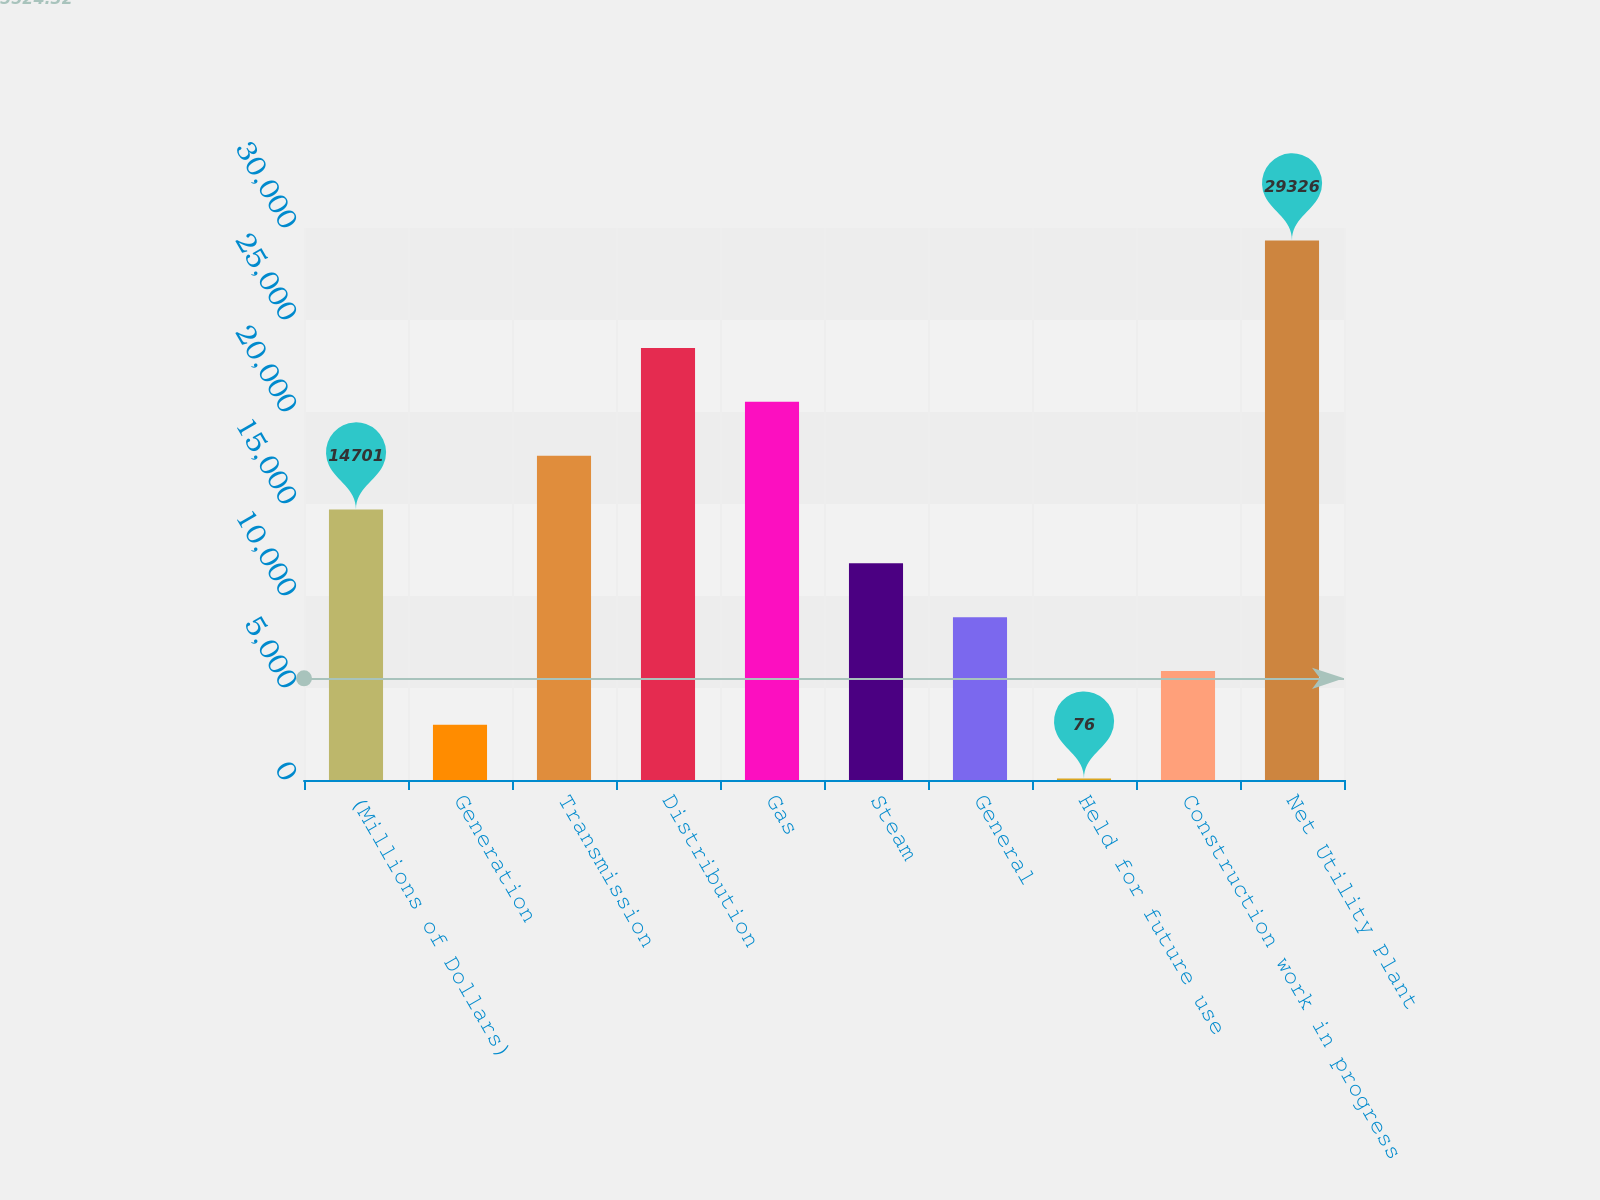<chart> <loc_0><loc_0><loc_500><loc_500><bar_chart><fcel>(Millions of Dollars)<fcel>Generation<fcel>Transmission<fcel>Distribution<fcel>Gas<fcel>Steam<fcel>General<fcel>Held for future use<fcel>Construction work in progress<fcel>Net Utility Plant<nl><fcel>14701<fcel>3001<fcel>17626<fcel>23476<fcel>20551<fcel>11776<fcel>8851<fcel>76<fcel>5926<fcel>29326<nl></chart> 